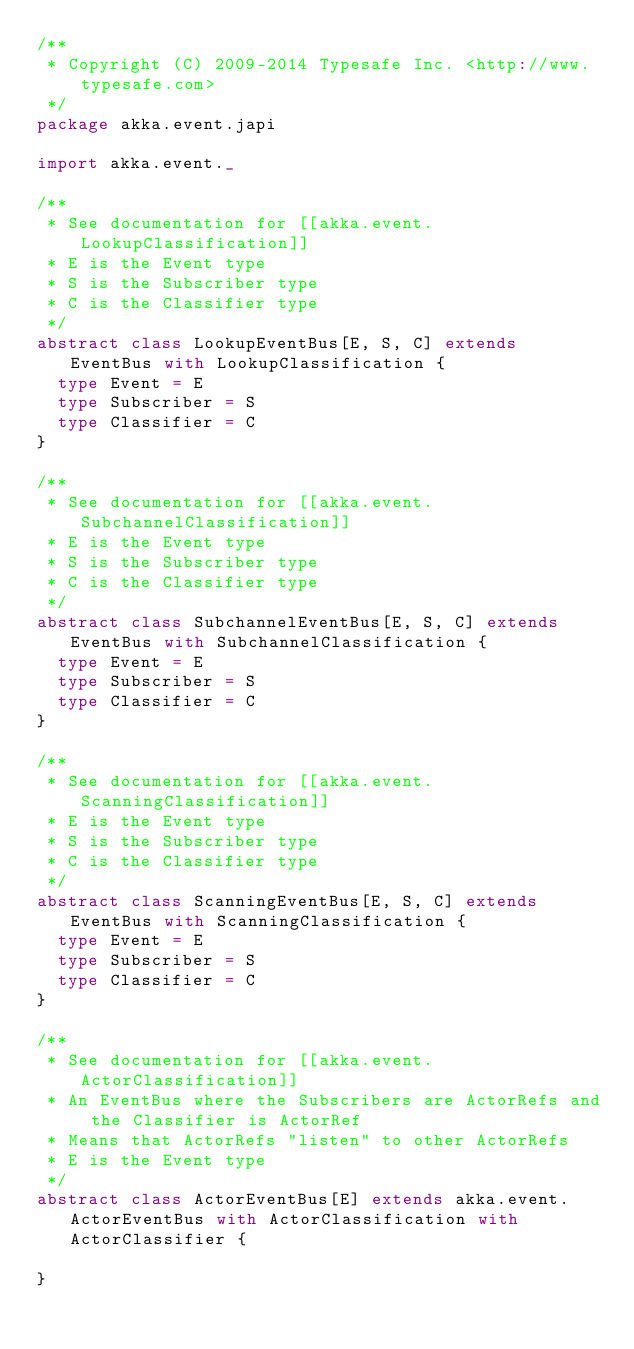Convert code to text. <code><loc_0><loc_0><loc_500><loc_500><_Scala_>/**
 * Copyright (C) 2009-2014 Typesafe Inc. <http://www.typesafe.com>
 */
package akka.event.japi

import akka.event._

/**
 * See documentation for [[akka.event.LookupClassification]]
 * E is the Event type
 * S is the Subscriber type
 * C is the Classifier type
 */
abstract class LookupEventBus[E, S, C] extends EventBus with LookupClassification {
  type Event = E
  type Subscriber = S
  type Classifier = C
}

/**
 * See documentation for [[akka.event.SubchannelClassification]]
 * E is the Event type
 * S is the Subscriber type
 * C is the Classifier type
 */
abstract class SubchannelEventBus[E, S, C] extends EventBus with SubchannelClassification {
  type Event = E
  type Subscriber = S
  type Classifier = C
}

/**
 * See documentation for [[akka.event.ScanningClassification]]
 * E is the Event type
 * S is the Subscriber type
 * C is the Classifier type
 */
abstract class ScanningEventBus[E, S, C] extends EventBus with ScanningClassification {
  type Event = E
  type Subscriber = S
  type Classifier = C
}

/**
 * See documentation for [[akka.event.ActorClassification]]
 * An EventBus where the Subscribers are ActorRefs and the Classifier is ActorRef
 * Means that ActorRefs "listen" to other ActorRefs
 * E is the Event type
 */
abstract class ActorEventBus[E] extends akka.event.ActorEventBus with ActorClassification with ActorClassifier {

}
</code> 